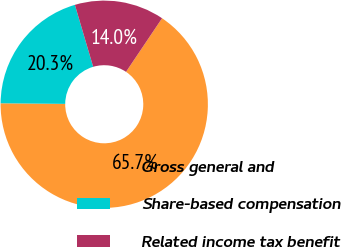Convert chart to OTSL. <chart><loc_0><loc_0><loc_500><loc_500><pie_chart><fcel>Gross general and<fcel>Share-based compensation<fcel>Related income tax benefit<nl><fcel>65.73%<fcel>20.28%<fcel>13.99%<nl></chart> 